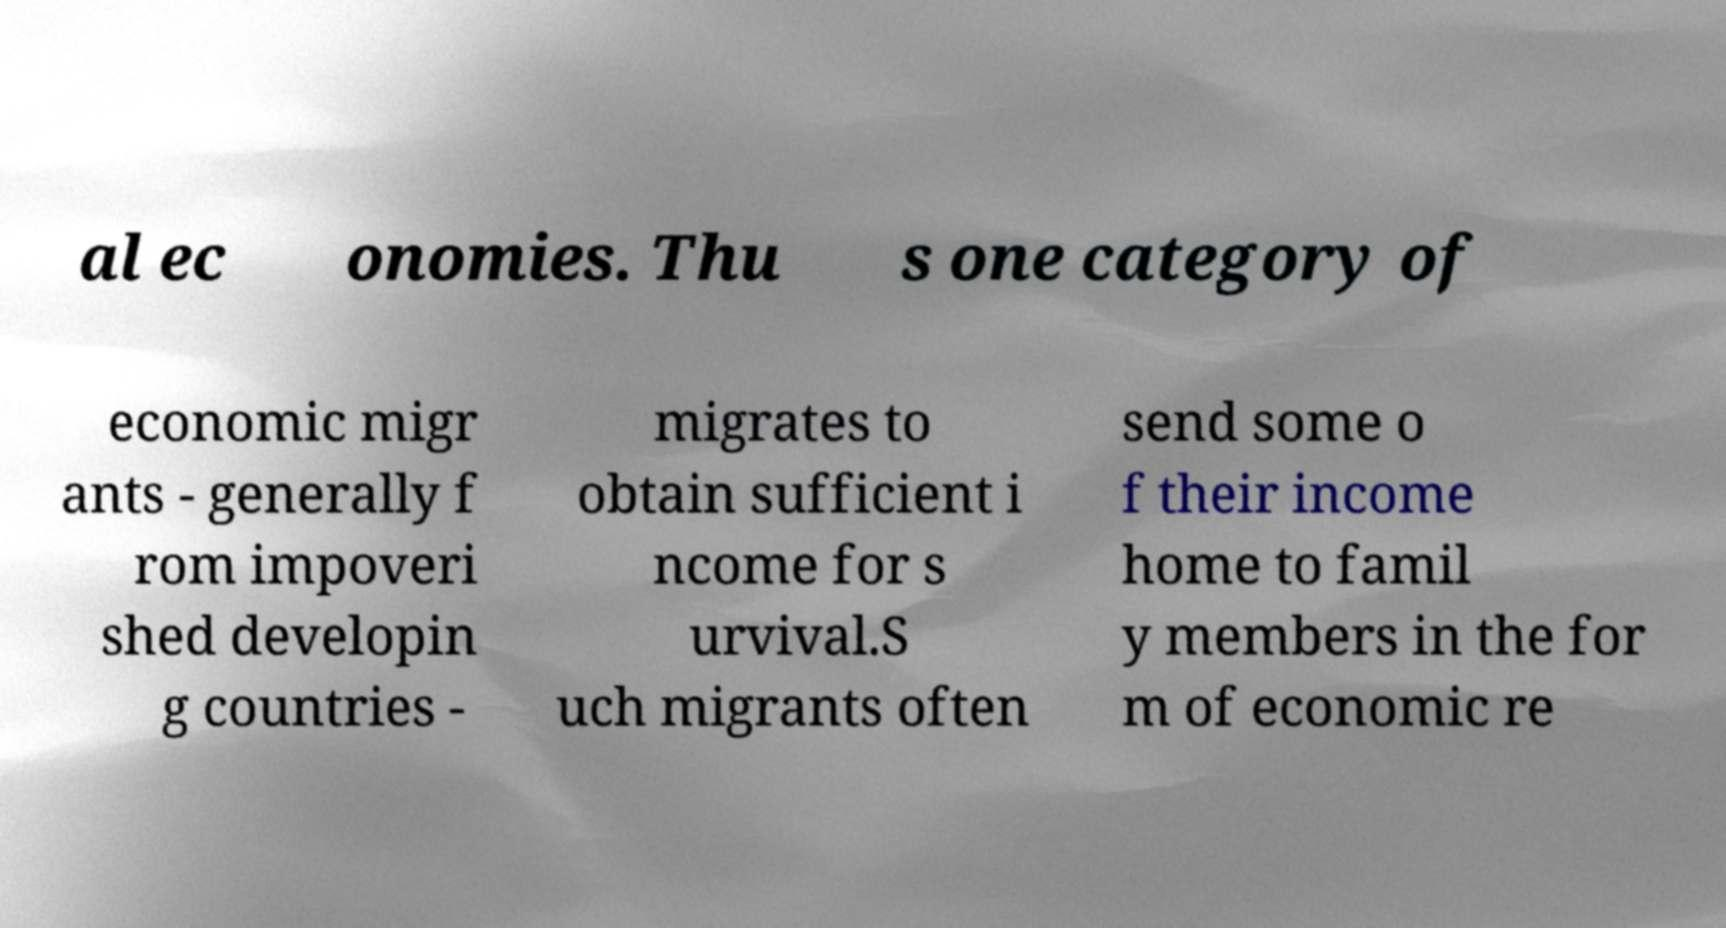I need the written content from this picture converted into text. Can you do that? al ec onomies. Thu s one category of economic migr ants - generally f rom impoveri shed developin g countries - migrates to obtain sufficient i ncome for s urvival.S uch migrants often send some o f their income home to famil y members in the for m of economic re 